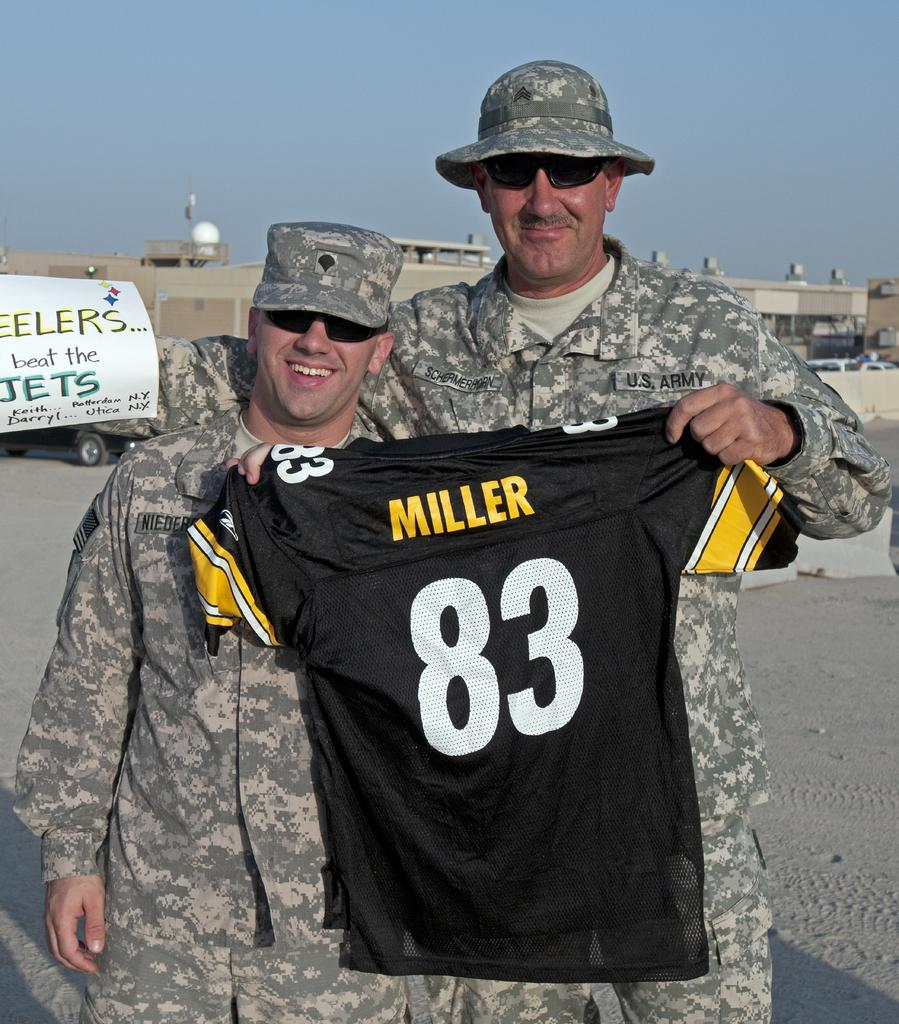<image>
Render a clear and concise summary of the photo. Two soldiers stand side by side, one holding a Miller 83 shirt. 